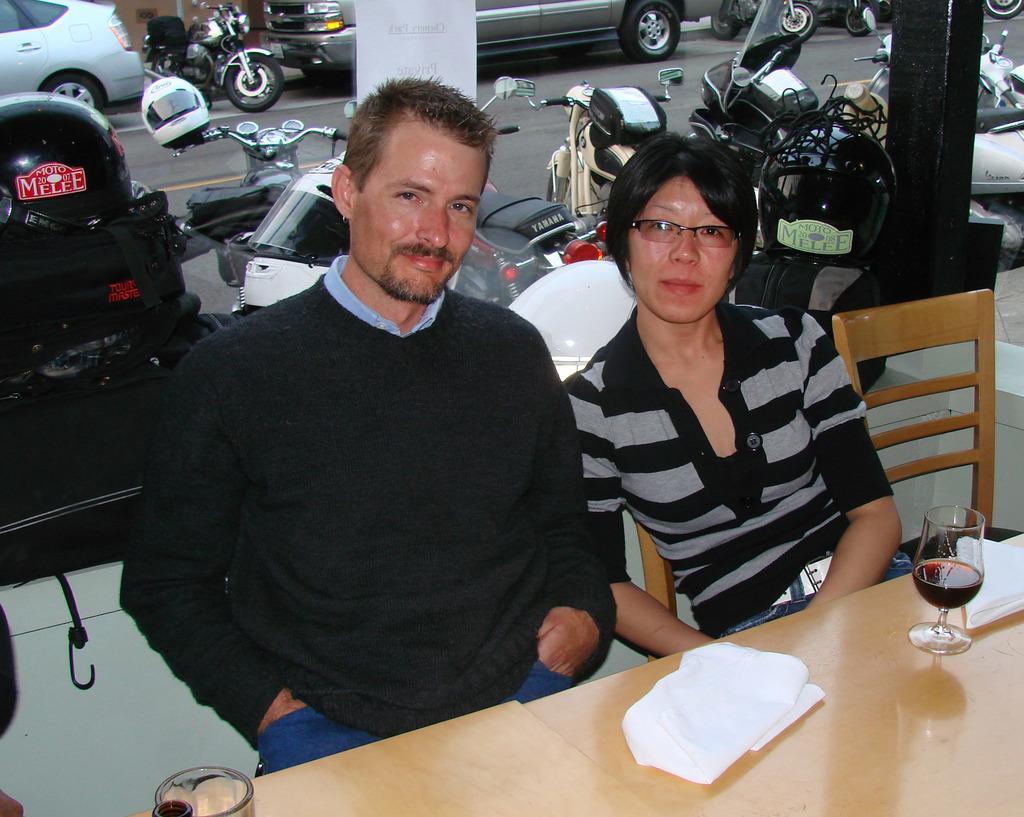Could you give a brief overview of what you see in this image? Man in black t-shirt and woman in black and grey t-shirt are sitting on chair in front of table on which glass and tissue papers are placed. Behind them, we see many bikes parked on road and we even see cars are also parked on road. We see white pillar behind these people. 